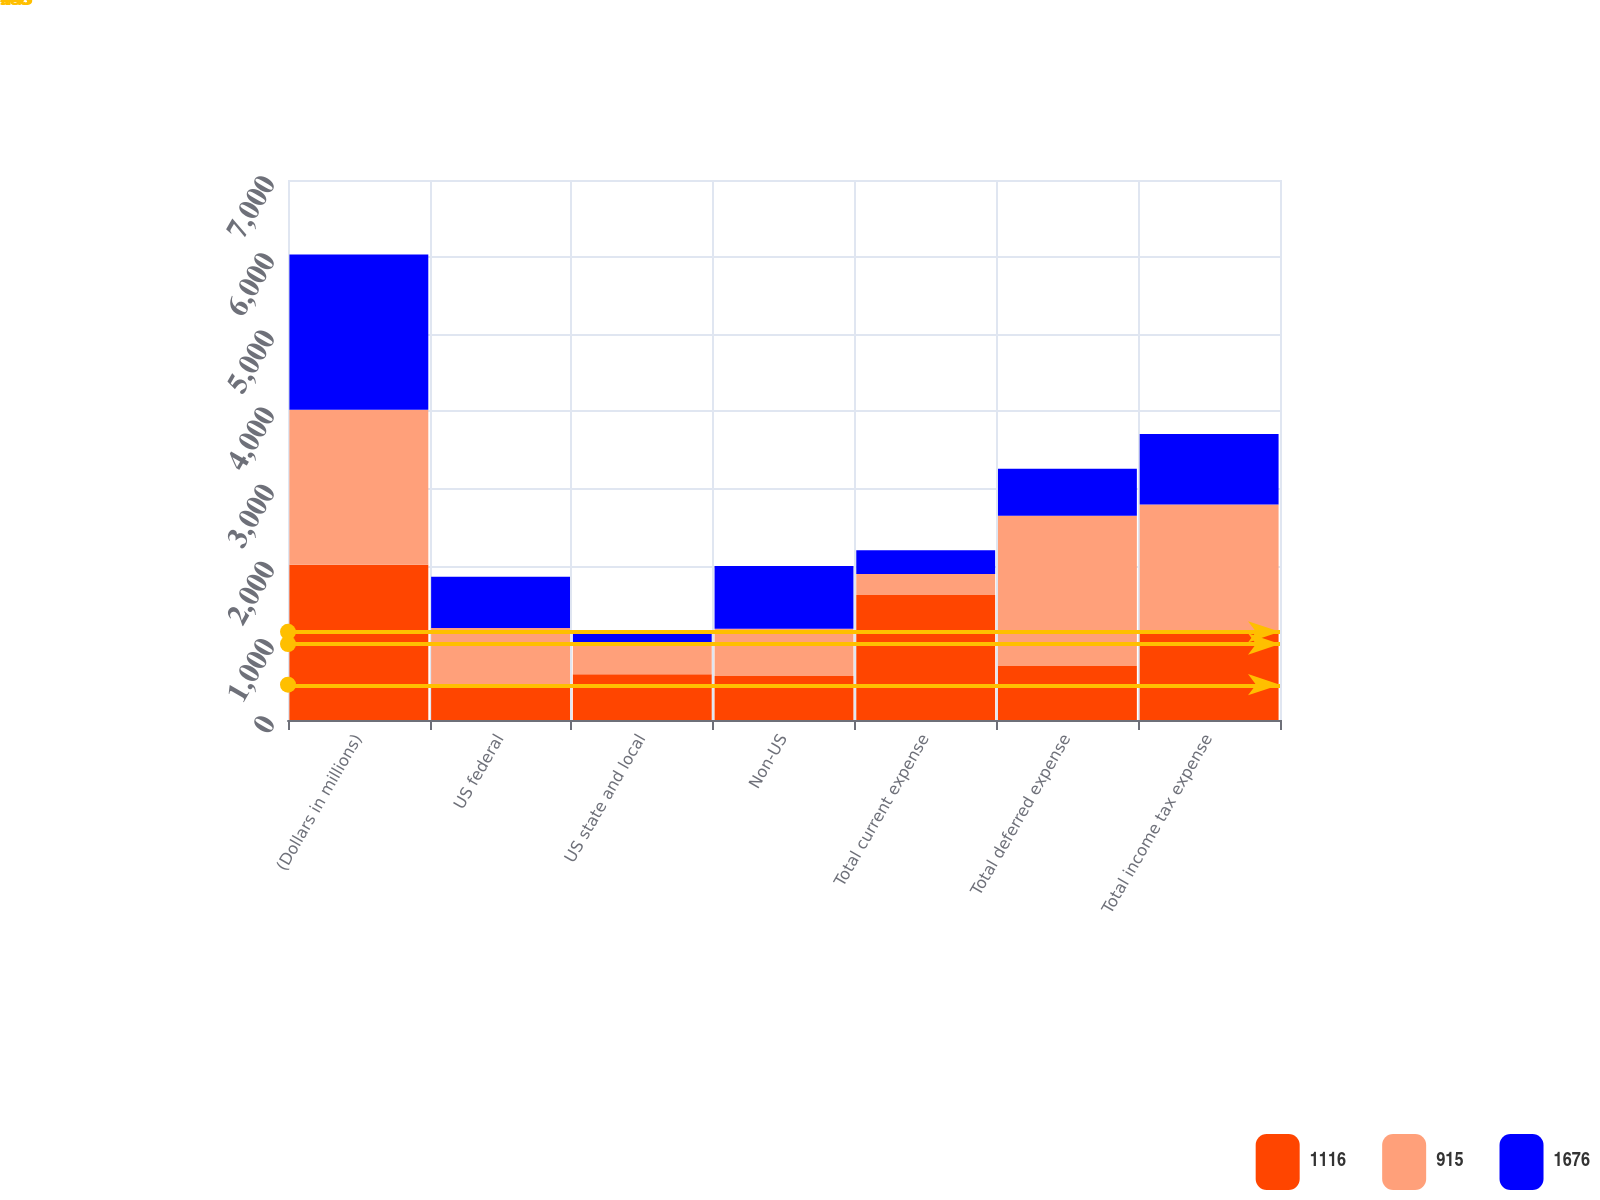Convert chart to OTSL. <chart><loc_0><loc_0><loc_500><loc_500><stacked_bar_chart><ecel><fcel>(Dollars in millions)<fcel>US federal<fcel>US state and local<fcel>Non-US<fcel>Total current expense<fcel>Total deferred expense<fcel>Total income tax expense<nl><fcel>1116<fcel>2012<fcel>458<fcel>592<fcel>569<fcel>1619<fcel>699.5<fcel>1116<nl><fcel>915<fcel>2011<fcel>733<fcel>393<fcel>613<fcel>273<fcel>1949<fcel>1676<nl><fcel>1676<fcel>2010<fcel>666<fcel>158<fcel>815<fcel>307<fcel>608<fcel>915<nl></chart> 